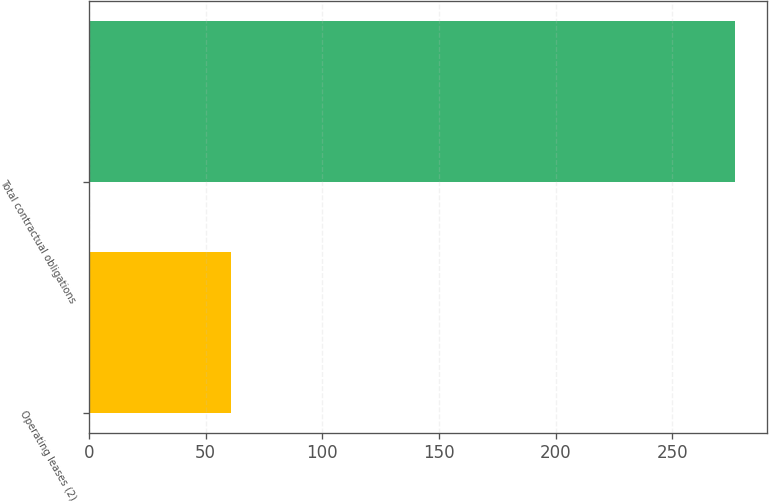Convert chart. <chart><loc_0><loc_0><loc_500><loc_500><bar_chart><fcel>Operating leases (2)<fcel>Total contractual obligations<nl><fcel>61<fcel>277<nl></chart> 